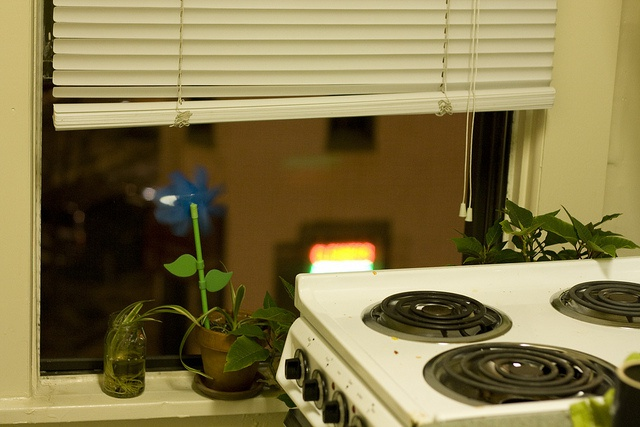Describe the objects in this image and their specific colors. I can see oven in tan, beige, black, and olive tones, potted plant in tan, black, and darkgreen tones, and potted plant in tan, black, olive, and darkgreen tones in this image. 